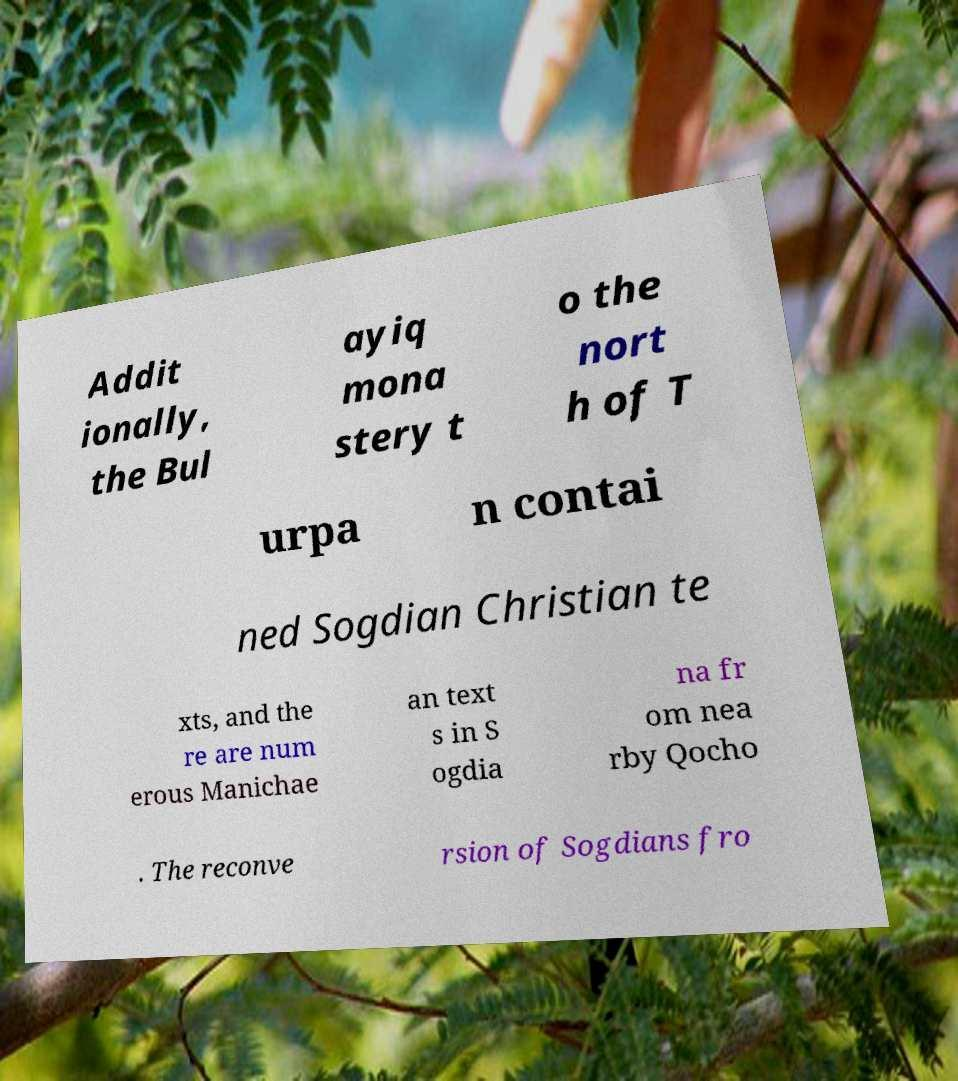For documentation purposes, I need the text within this image transcribed. Could you provide that? Addit ionally, the Bul ayiq mona stery t o the nort h of T urpa n contai ned Sogdian Christian te xts, and the re are num erous Manichae an text s in S ogdia na fr om nea rby Qocho . The reconve rsion of Sogdians fro 